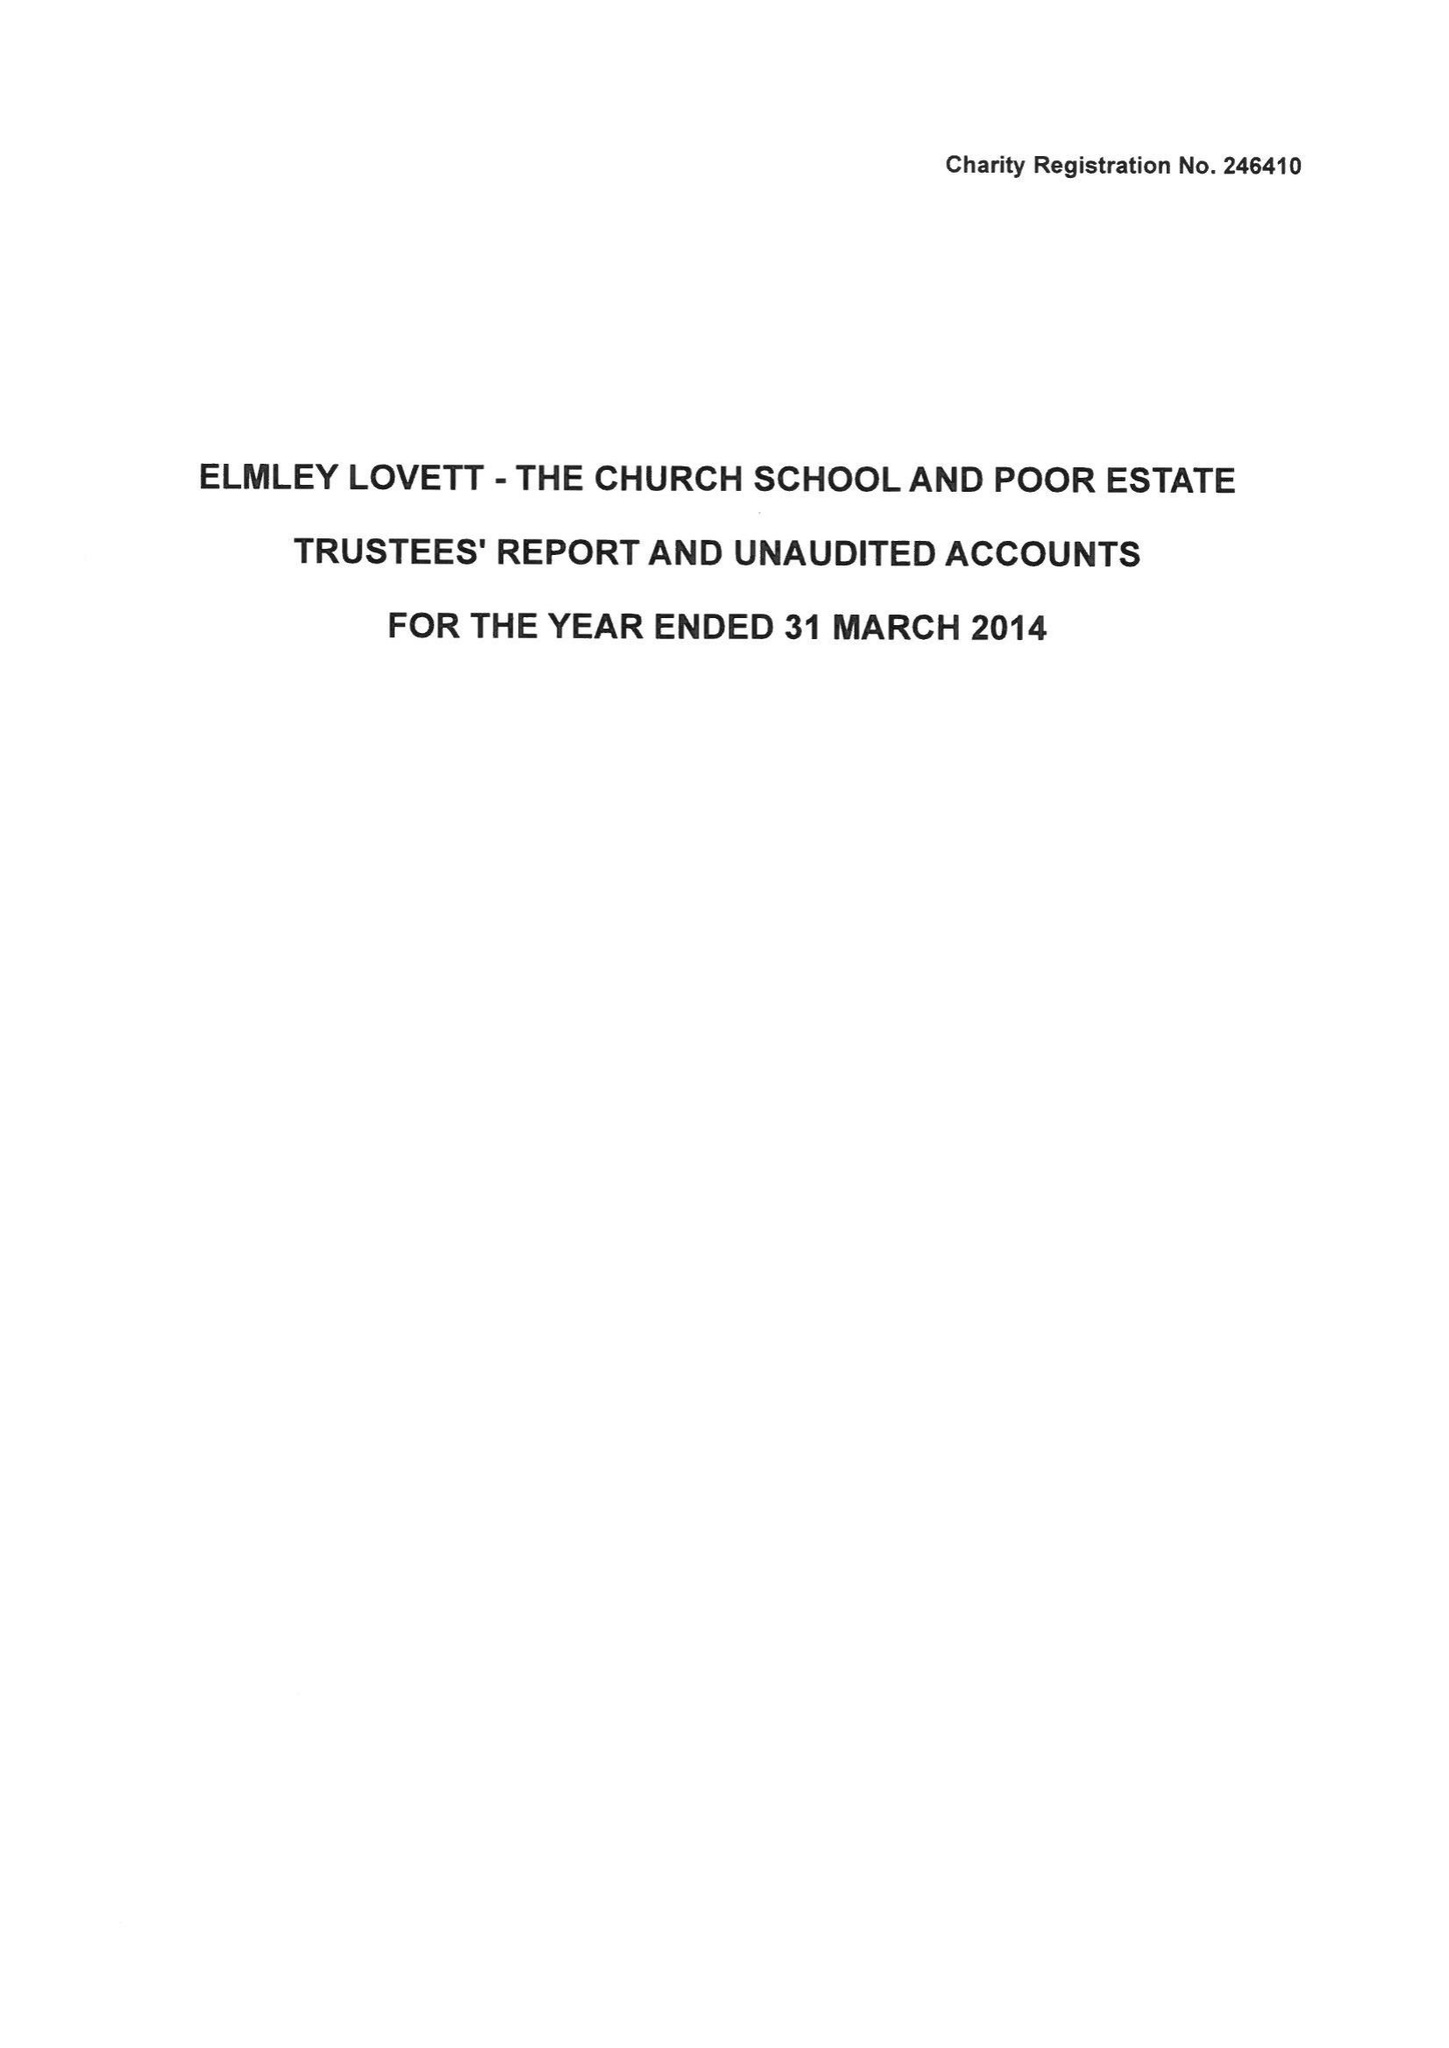What is the value for the address__postcode?
Answer the question using a single word or phrase. WR9 0PT 